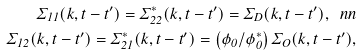<formula> <loc_0><loc_0><loc_500><loc_500>\Sigma _ { 1 1 } ( k , t - t ^ { \prime } ) = \Sigma ^ { \ast } _ { 2 2 } ( k , t - t ^ { \prime } ) = \Sigma _ { D } ( k , t - t ^ { \prime } ) , \ n n \\ \Sigma _ { 1 2 } ( k , t - t ^ { \prime } ) = \Sigma ^ { \ast } _ { 2 1 } ( k , t - t ^ { \prime } ) = \left ( \phi _ { 0 } / \phi ^ { \ast } _ { 0 } \right ) \Sigma _ { O } ( k , t - t ^ { \prime } ) ,</formula> 